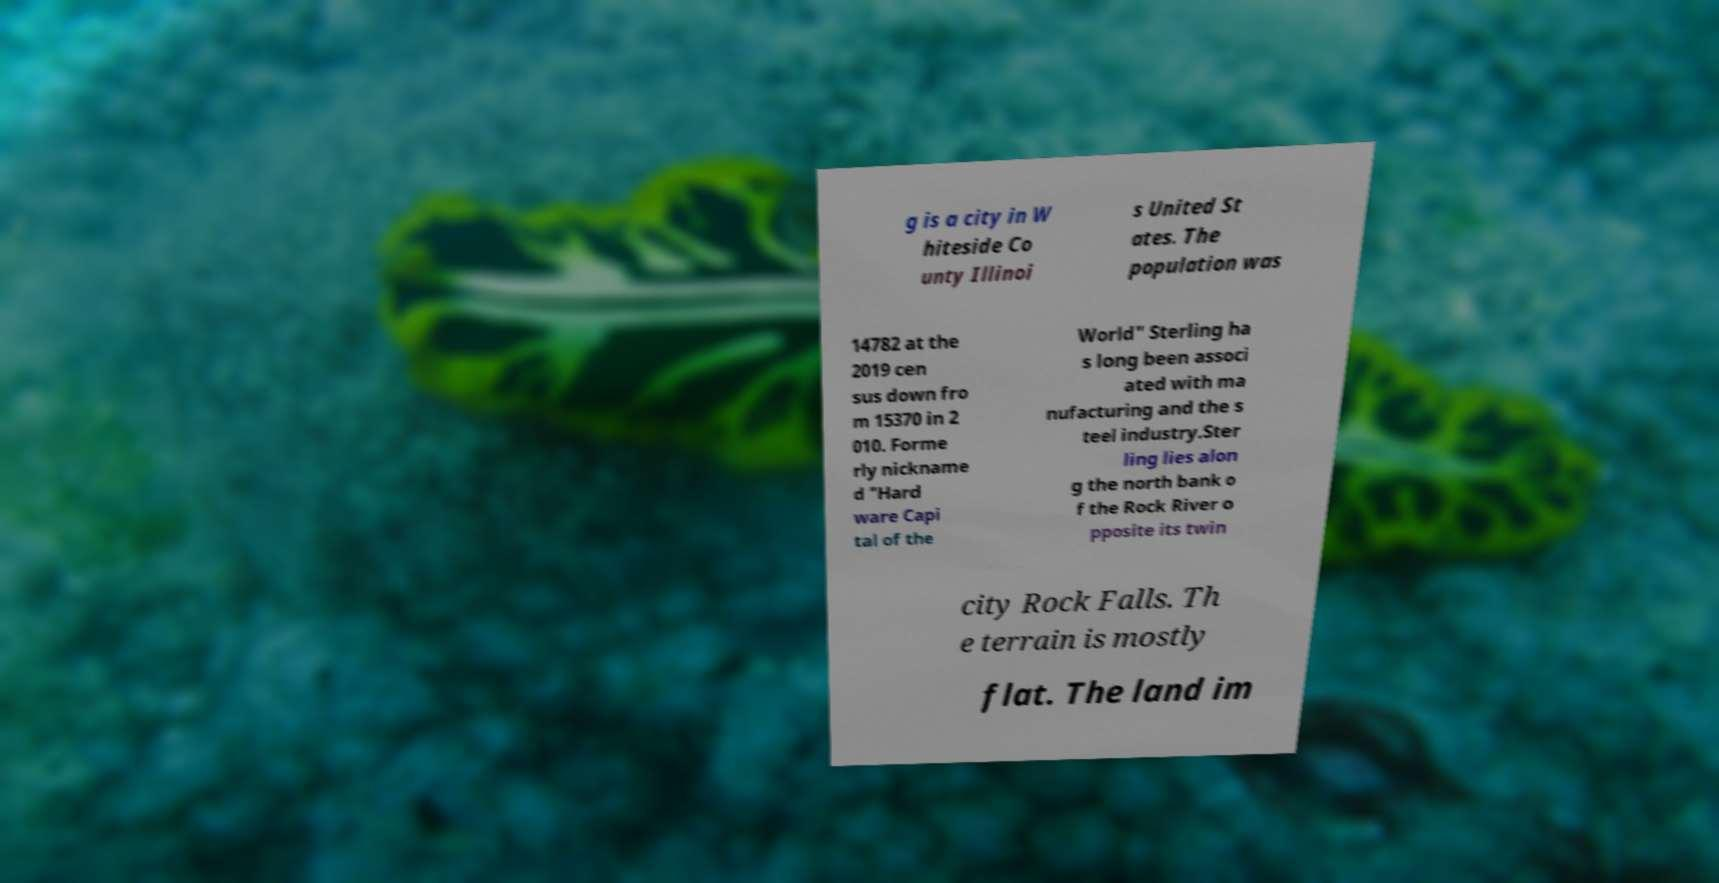Please read and relay the text visible in this image. What does it say? g is a city in W hiteside Co unty Illinoi s United St ates. The population was 14782 at the 2019 cen sus down fro m 15370 in 2 010. Forme rly nickname d "Hard ware Capi tal of the World" Sterling ha s long been associ ated with ma nufacturing and the s teel industry.Ster ling lies alon g the north bank o f the Rock River o pposite its twin city Rock Falls. Th e terrain is mostly flat. The land im 